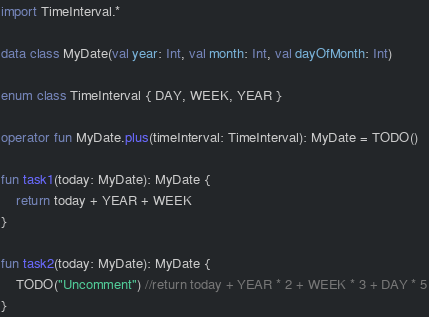<code> <loc_0><loc_0><loc_500><loc_500><_Kotlin_>import TimeInterval.*

data class MyDate(val year: Int, val month: Int, val dayOfMonth: Int)

enum class TimeInterval { DAY, WEEK, YEAR }

operator fun MyDate.plus(timeInterval: TimeInterval): MyDate = TODO()

fun task1(today: MyDate): MyDate {
    return today + YEAR + WEEK
}

fun task2(today: MyDate): MyDate {
    TODO("Uncomment") //return today + YEAR * 2 + WEEK * 3 + DAY * 5
}</code> 